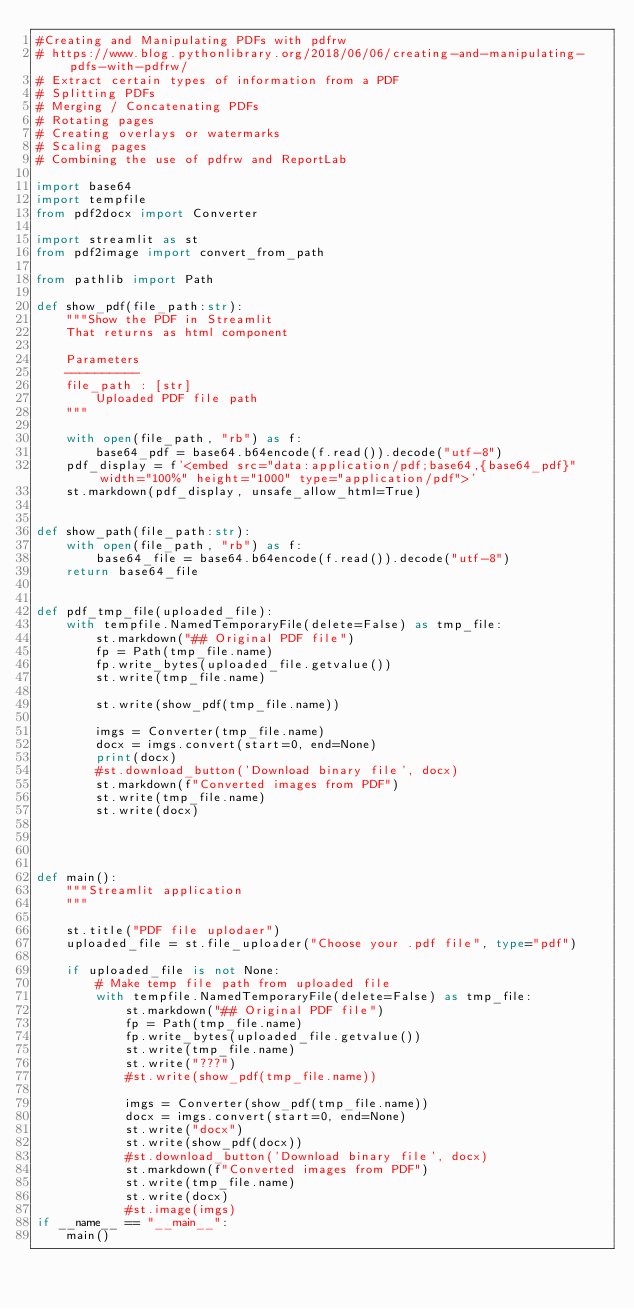<code> <loc_0><loc_0><loc_500><loc_500><_Python_>#Creating and Manipulating PDFs with pdfrw
# https://www.blog.pythonlibrary.org/2018/06/06/creating-and-manipulating-pdfs-with-pdfrw/
# Extract certain types of information from a PDF
# Splitting PDFs
# Merging / Concatenating PDFs
# Rotating pages
# Creating overlays or watermarks
# Scaling pages
# Combining the use of pdfrw and ReportLab

import base64
import tempfile
from pdf2docx import Converter

import streamlit as st
from pdf2image import convert_from_path

from pathlib import Path

def show_pdf(file_path:str):
    """Show the PDF in Streamlit
    That returns as html component

    Parameters
    ----------
    file_path : [str]
        Uploaded PDF file path
    """

    with open(file_path, "rb") as f:
        base64_pdf = base64.b64encode(f.read()).decode("utf-8")
    pdf_display = f'<embed src="data:application/pdf;base64,{base64_pdf}" width="100%" height="1000" type="application/pdf">'
    st.markdown(pdf_display, unsafe_allow_html=True)


def show_path(file_path:str):
    with open(file_path, "rb") as f:
        base64_file = base64.b64encode(f.read()).decode("utf-8")
    return base64_file


def pdf_tmp_file(uploaded_file):
    with tempfile.NamedTemporaryFile(delete=False) as tmp_file:
        st.markdown("## Original PDF file")
        fp = Path(tmp_file.name)
        fp.write_bytes(uploaded_file.getvalue())
        st.write(tmp_file.name)
        
        st.write(show_pdf(tmp_file.name)) 

        imgs = Converter(tmp_file.name)
        docx = imgs.convert(start=0, end=None)
        print(docx)
        #st.download_button('Download binary file', docx)
        st.markdown(f"Converted images from PDF")
        st.write(tmp_file.name)
        st.write(docx)




def main():
    """Streamlit application
    """

    st.title("PDF file uplodaer")
    uploaded_file = st.file_uploader("Choose your .pdf file", type="pdf")

    if uploaded_file is not None:
        # Make temp file path from uploaded file
        with tempfile.NamedTemporaryFile(delete=False) as tmp_file:
            st.markdown("## Original PDF file")
            fp = Path(tmp_file.name)
            fp.write_bytes(uploaded_file.getvalue())
            st.write(tmp_file.name)
            st.write("???")
            #st.write(show_pdf(tmp_file.name)) 

            imgs = Converter(show_pdf(tmp_file.name))
            docx = imgs.convert(start=0, end=None)
            st.write("docx")
            st.write(show_pdf(docx))
            #st.download_button('Download binary file', docx)
            st.markdown(f"Converted images from PDF")
            st.write(tmp_file.name)
            st.write(docx)
            #st.image(imgs)
if __name__ == "__main__":
    main()
    </code> 